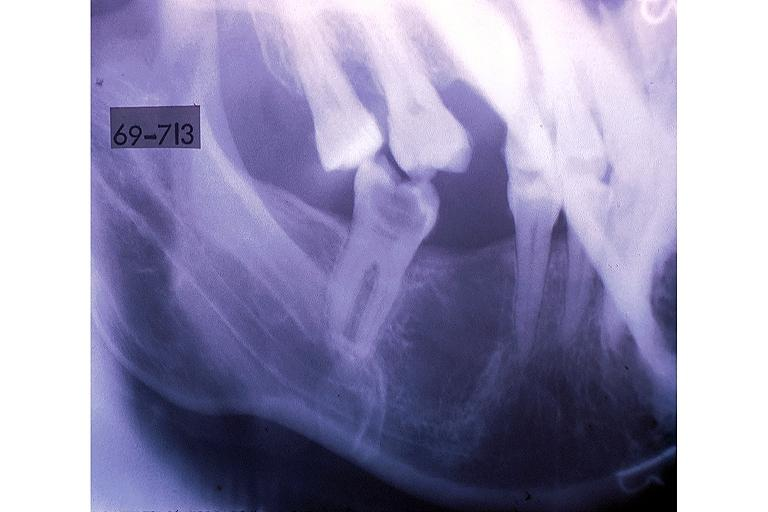what does this image show?
Answer the question using a single word or phrase. Hematopoietic bone marrow defect 